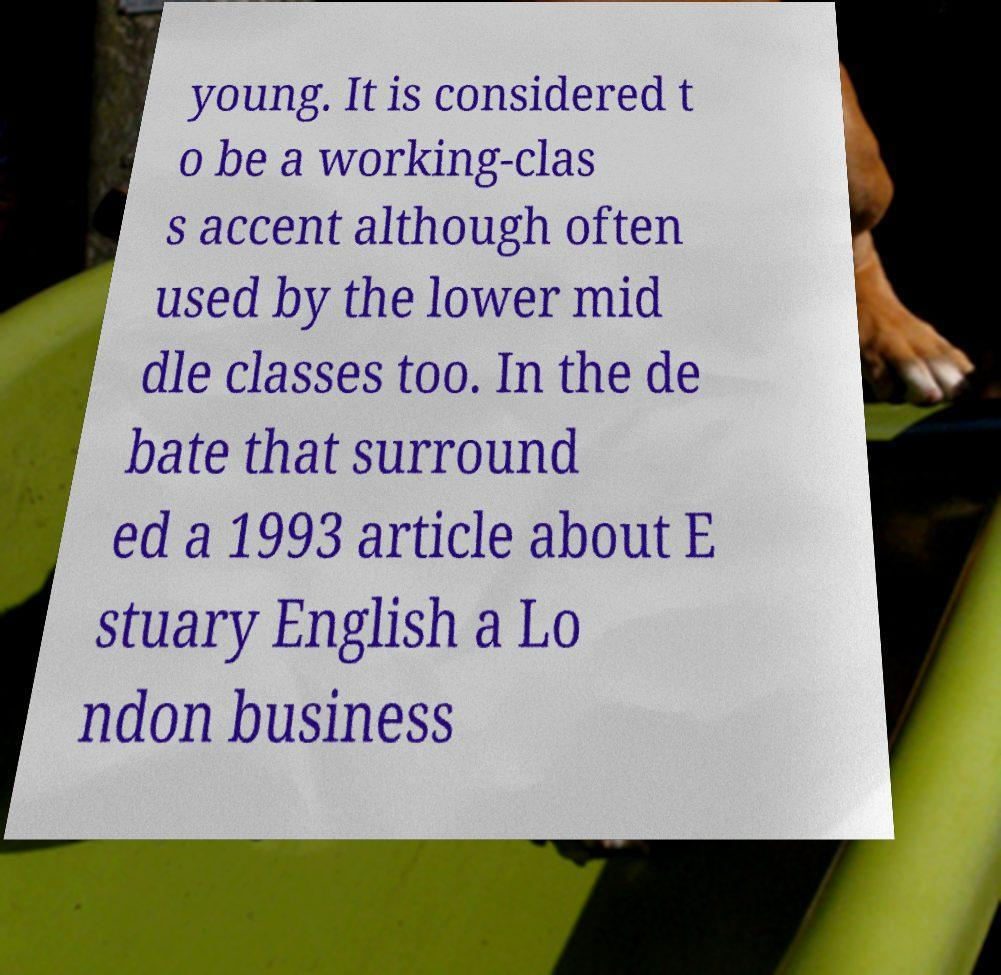Can you read and provide the text displayed in the image?This photo seems to have some interesting text. Can you extract and type it out for me? young. It is considered t o be a working-clas s accent although often used by the lower mid dle classes too. In the de bate that surround ed a 1993 article about E stuary English a Lo ndon business 